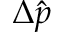Convert formula to latex. <formula><loc_0><loc_0><loc_500><loc_500>\Delta \hat { p }</formula> 